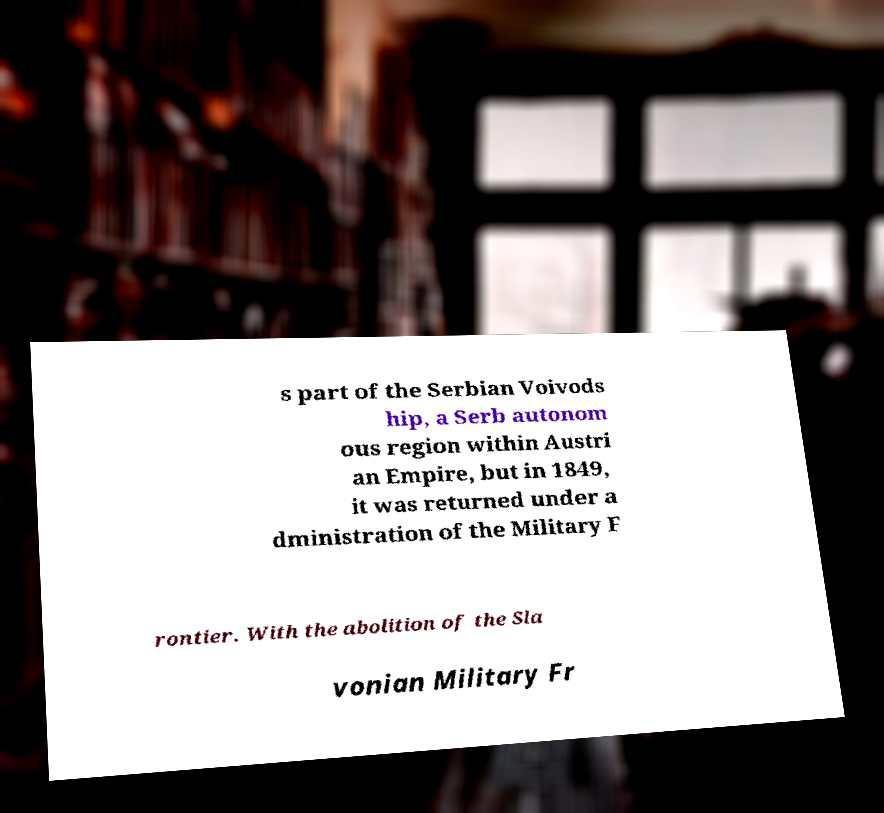There's text embedded in this image that I need extracted. Can you transcribe it verbatim? s part of the Serbian Voivods hip, a Serb autonom ous region within Austri an Empire, but in 1849, it was returned under a dministration of the Military F rontier. With the abolition of the Sla vonian Military Fr 